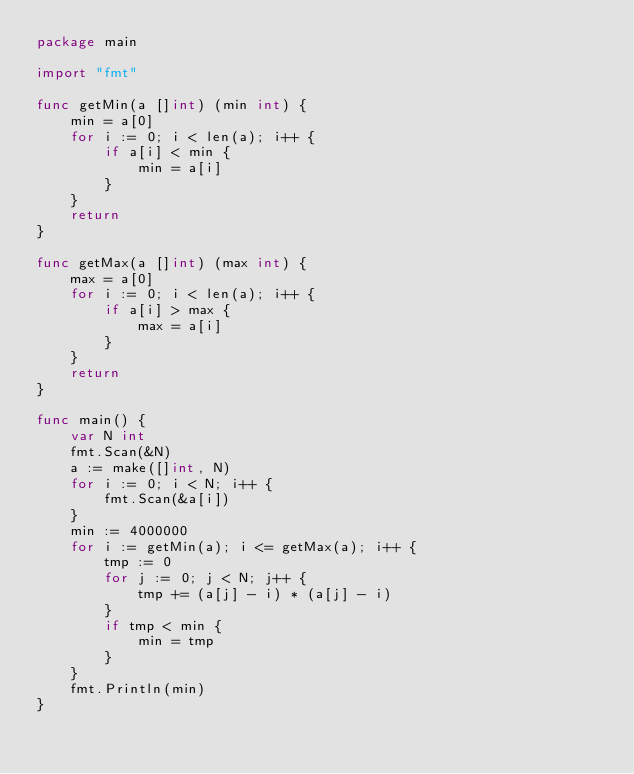Convert code to text. <code><loc_0><loc_0><loc_500><loc_500><_Go_>package main

import "fmt"

func getMin(a []int) (min int) {
	min = a[0]
	for i := 0; i < len(a); i++ {
		if a[i] < min {
			min = a[i]
		}
	}
	return
}

func getMax(a []int) (max int) {
	max = a[0]
	for i := 0; i < len(a); i++ {
		if a[i] > max {
			max = a[i]
		}
	}
	return
}

func main() {
	var N int
	fmt.Scan(&N)
	a := make([]int, N)
	for i := 0; i < N; i++ {
		fmt.Scan(&a[i])
	}
	min := 4000000
	for i := getMin(a); i <= getMax(a); i++ {
		tmp := 0
		for j := 0; j < N; j++ {
			tmp += (a[j] - i) * (a[j] - i)
		}
		if tmp < min {
			min = tmp
		}
	}
	fmt.Println(min)
}
</code> 